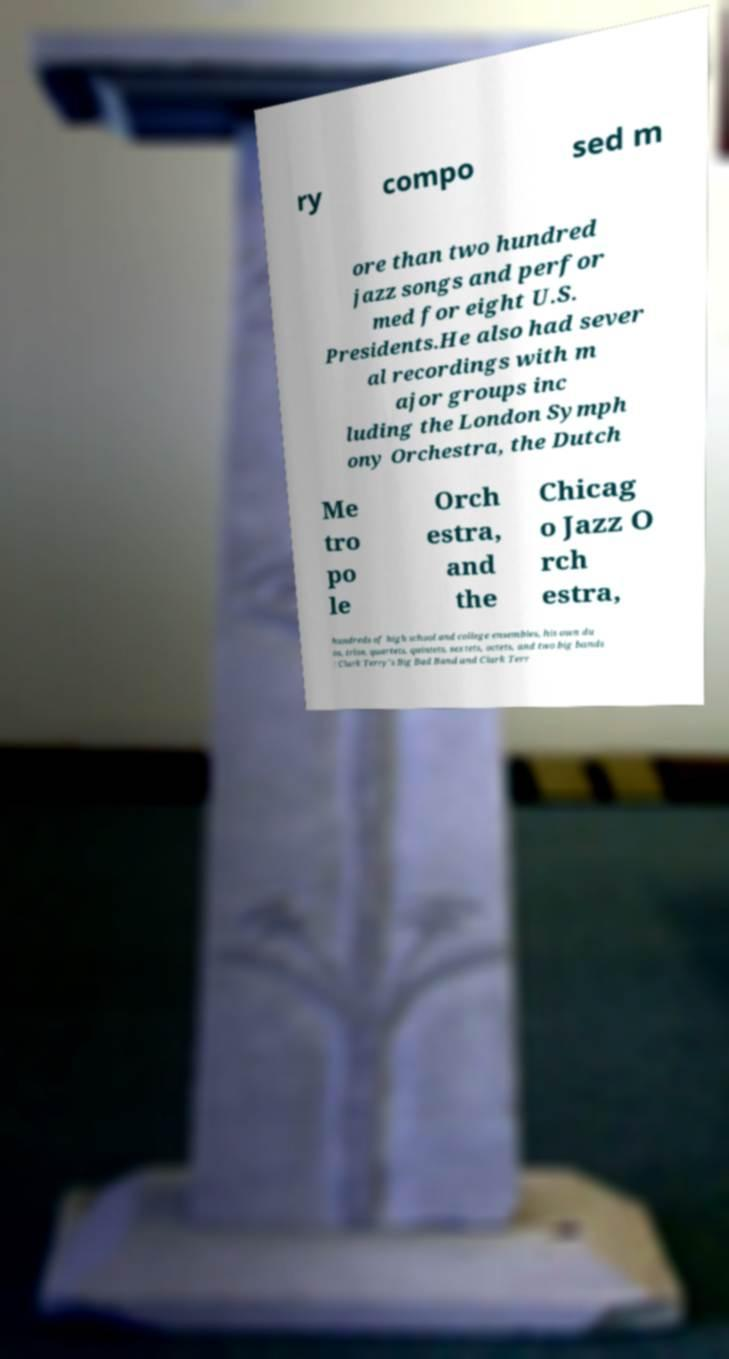Can you accurately transcribe the text from the provided image for me? ry compo sed m ore than two hundred jazz songs and perfor med for eight U.S. Presidents.He also had sever al recordings with m ajor groups inc luding the London Symph ony Orchestra, the Dutch Me tro po le Orch estra, and the Chicag o Jazz O rch estra, hundreds of high school and college ensembles, his own du os, trios, quartets, quintets, sextets, octets, and two big bands : Clark Terry's Big Bad Band and Clark Terr 